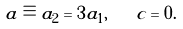<formula> <loc_0><loc_0><loc_500><loc_500>a \equiv a _ { 2 } = 3 a _ { 1 } , \quad c = 0 .</formula> 